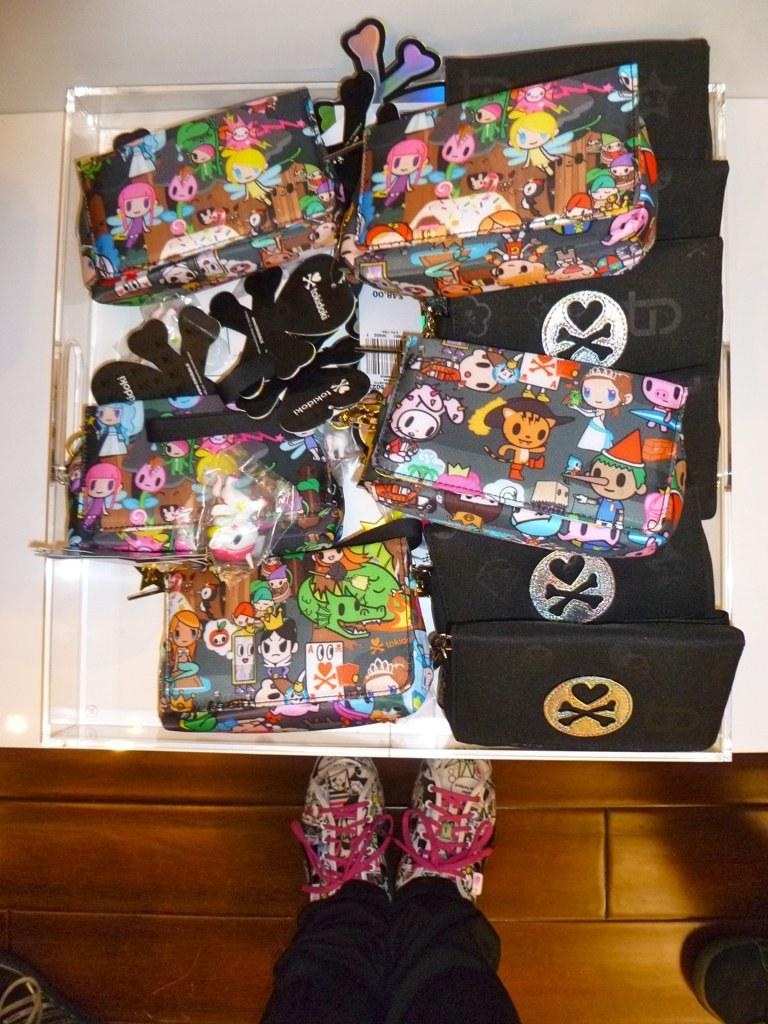What is on the table in the image? There is a box of handbags on a table. Can you describe the handbags in the image? There is a handbag with cartoon pictures on it and a black-colored handbag. What else can be seen in the image? A person's shoe is visible. What type of battle is taking place in the image? There is no battle present in the image. Can you tell me where the hydrant is located in the image? There is no hydrant present in the image. 